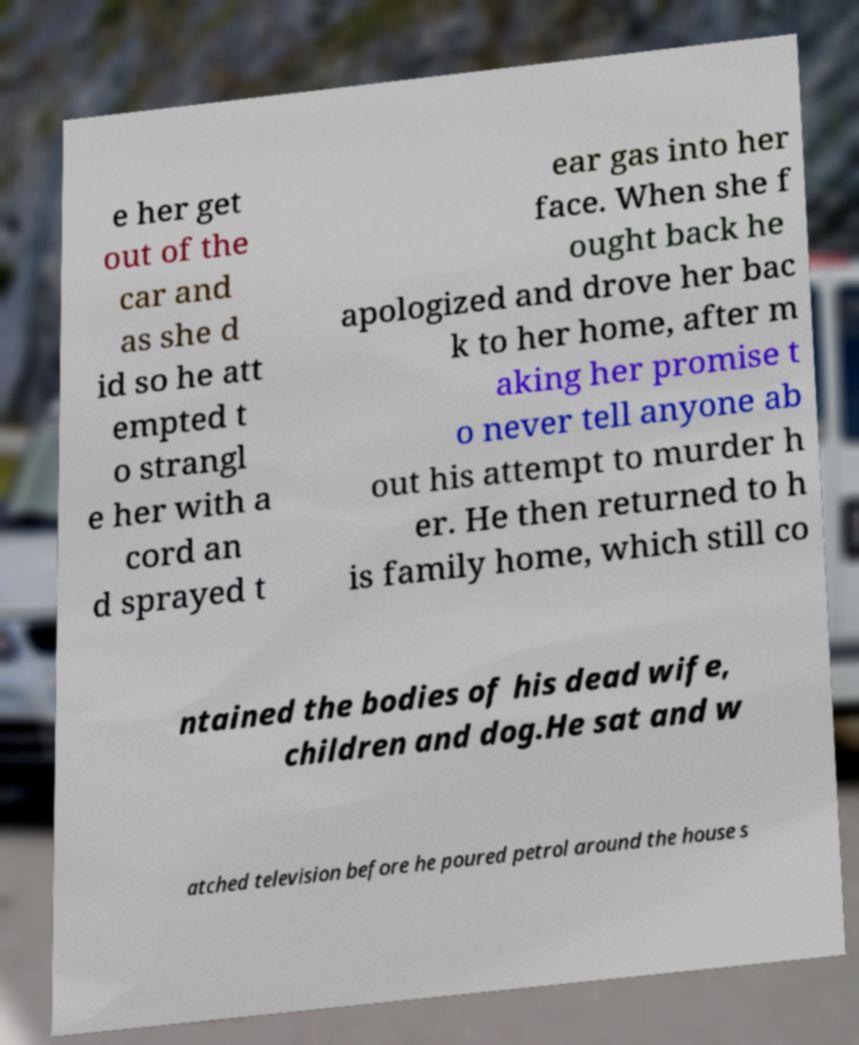What messages or text are displayed in this image? I need them in a readable, typed format. e her get out of the car and as she d id so he att empted t o strangl e her with a cord an d sprayed t ear gas into her face. When she f ought back he apologized and drove her bac k to her home, after m aking her promise t o never tell anyone ab out his attempt to murder h er. He then returned to h is family home, which still co ntained the bodies of his dead wife, children and dog.He sat and w atched television before he poured petrol around the house s 